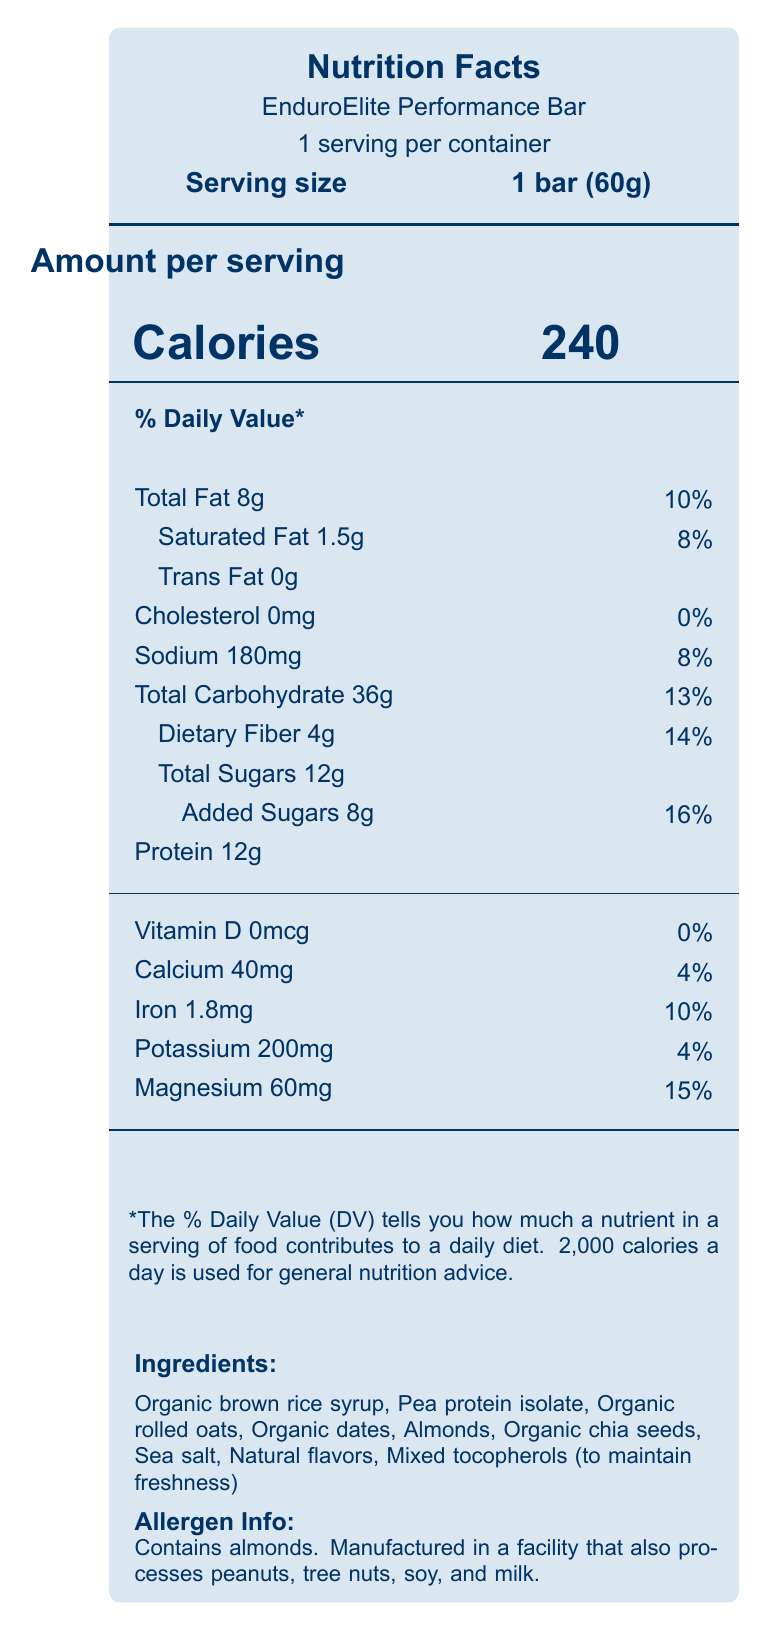what is the serving size of the EnduroElite Performance Bar? The serving size is explicitly listed as '1 bar (60g)' under the product name on the document.
Answer: 1 bar (60g) what is the total amount of dietary fiber per serving? The document states the dietary fiber content as '4g' and provides a daily value percentage of 14%.
Answer: 4g how much sodium does one serving contain? The sodium content per serving is listed as '180mg,' with a daily value percentage of 8%.
Answer: 180mg what is the primary ingredient in the EnduroElite Performance Bar? The first ingredient listed under the 'Ingredients' section is 'Organic brown rice syrup.'
Answer: Organic brown rice syrup does the EnduroElite Performance Bar contain any artificial sweeteners? One of the key features of the bar mentions 'No artificial sweeteners or preservatives,' indicating it does not contain artificial sweeteners.
Answer: No what percentage of the daily value for calcium does one bar provide? A. 2% B. 4% C. 8% D. 10% The document lists the calcium content as '40mg,' which corresponds to 4% of the daily value.
Answer: B. 4% how many grams of added sugars are in one serving of the EnduroElite Performance Bar? The document clearly states 'Added Sugars 8g' with a corresponding daily value of 16%.
Answer: 8g is the EnduroElite Performance Bar suitable for someone with a peanut allergy? The allergen information states that the bar is manufactured in a facility that processes peanuts, which could pose a risk for someone with a peanut allergy.
Answer: No how many calories are in one serving of the EnduroElite Performance Bar? The number of calories per serving is prominently displayed as '240' in the 'Amount per serving' section.
Answer: 240 what is the macronutrient ratio of carbohydrates to protein to fats in the EnduroElite Performance Bar? A. 50% : 25% : 25% B. 60% : 20% : 20% C. 55% : 25% : 20% D. 65% : 20% : 15% The macronutrient ratio is stated clearly under the 'macronutrient ratio' section: 'carbohydrates: 60%, protein: 20%, fats: 20%.'
Answer: B. 60% : 20% : 20% does the EnduroElite Performance Bar contain any trans fat? The document lists 'Trans Fat 0g,' indicating that there are no trans fats in the bar.
Answer: No summarize the key nutritional and health-related features of the EnduroElite Performance Bar. This summary encompasses all the highlighted features and key nutritional components listed throughout the document, including considerations for specific athlete needs.
Answer: The EnduroElite Performance Bar is designed for endurance athletes. It provides 240 calories per serving with a balanced macronutrient profile: 60% carbohydrates, 20% protein, and 20% fats. It includes essential electrolytes like sodium, potassium, and magnesium to support hydration and prolonged physical activity. The bar is high in complex carbohydrates for sustained energy, plant-based protein for muscle recovery, and contains no artificial sweeteners or preservatives. It also considers epidemiological factors to support immune function and reduce exercise-induced gastrointestinal distress, among other features. which key nutrients are listed to support hydration? The electrolyte content section lists sodium (180mg), potassium (200mg), and magnesium (60mg) as key nutrients to support hydration.
Answer: Sodium, potassium, magnesium what is the percentage daily value of magnesium in one serving of the EnduroElite Performance Bar? The document shows magnesium content as '60mg,' which corresponds to 15% of the daily value.
Answer: 15% does the EnduroElite Performance Bar contain any vitamins? The vitamin D section lists '0mcg' corresponding to '0%' daily value, indicating no vitamins are present in significant amounts.
Answer: No what are the benefits of the antioxidant-rich ingredients in the EnduroElite Performance Bar? One of the epidemiological considerations mentions that the bar uses antioxidant-rich ingredients to combat exercise-induced oxidative stress.
Answer: Combat exercise-induced oxidative stress what is the glycemic index level of the EnduroElite Performance Bar? The document states that the bar has a low glycemic index, but does not provide specific details or numerical values to conclude the exact glycemic index level.
Answer: Not enough information 